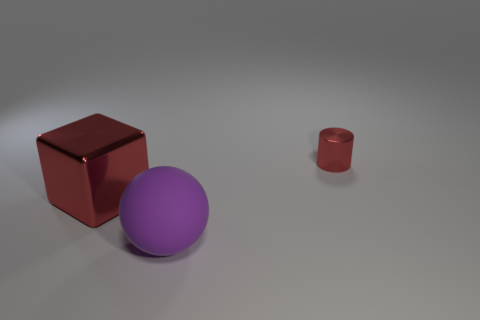Add 3 small cyan matte cubes. How many objects exist? 6 Subtract all balls. How many objects are left? 2 Subtract all small red balls. Subtract all small cylinders. How many objects are left? 2 Add 2 large rubber spheres. How many large rubber spheres are left? 3 Add 3 small cylinders. How many small cylinders exist? 4 Subtract 0 green blocks. How many objects are left? 3 